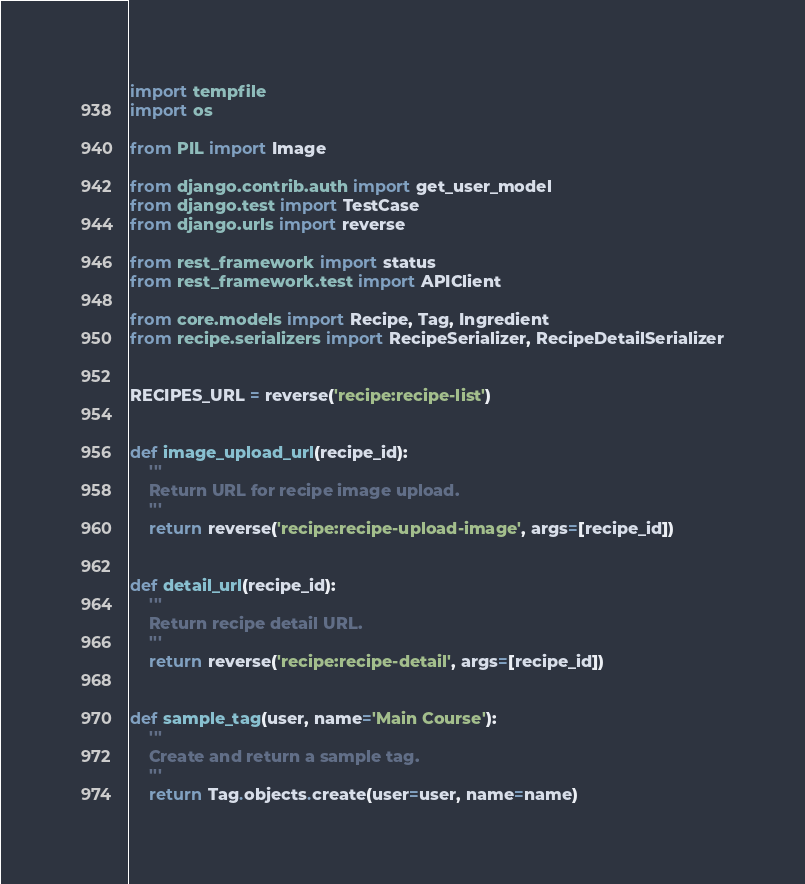<code> <loc_0><loc_0><loc_500><loc_500><_Python_>import tempfile
import os

from PIL import Image

from django.contrib.auth import get_user_model
from django.test import TestCase
from django.urls import reverse

from rest_framework import status
from rest_framework.test import APIClient

from core.models import Recipe, Tag, Ingredient
from recipe.serializers import RecipeSerializer, RecipeDetailSerializer


RECIPES_URL = reverse('recipe:recipe-list')


def image_upload_url(recipe_id):
    '''
    Return URL for recipe image upload.
    '''
    return reverse('recipe:recipe-upload-image', args=[recipe_id])


def detail_url(recipe_id):
    '''
    Return recipe detail URL.
    '''
    return reverse('recipe:recipe-detail', args=[recipe_id])


def sample_tag(user, name='Main Course'):
    '''
    Create and return a sample tag.
    '''
    return Tag.objects.create(user=user, name=name)

</code> 